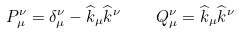<formula> <loc_0><loc_0><loc_500><loc_500>P _ { \mu } ^ { \nu } = \delta _ { \mu } ^ { \nu } - \widehat { k } _ { \mu } \widehat { k } ^ { \nu } \quad Q _ { \mu } ^ { \nu } = \widehat { k } _ { \mu } \widehat { k } ^ { \nu }</formula> 